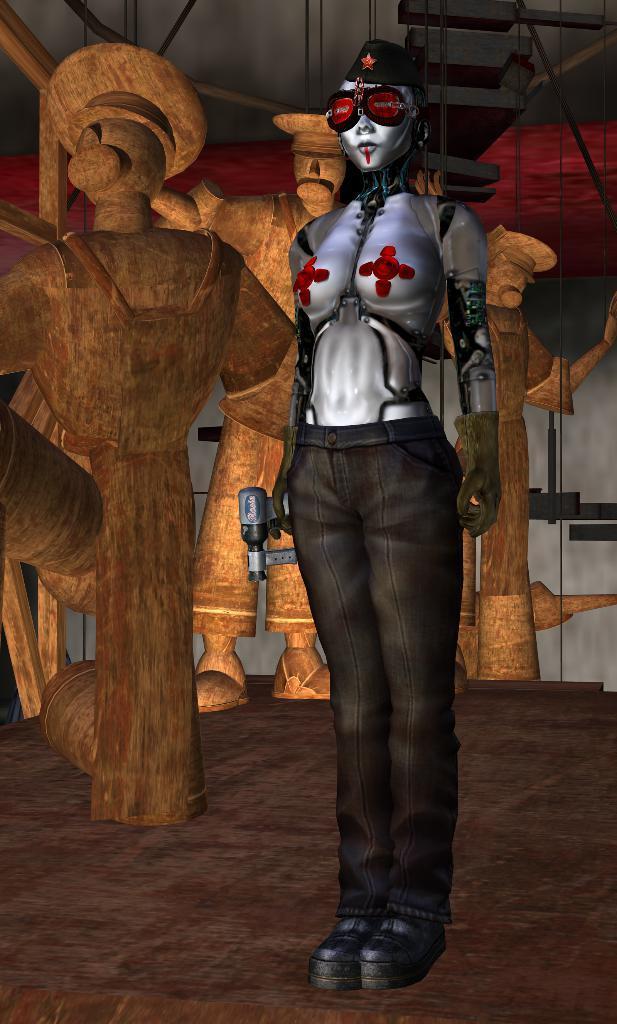How would you summarize this image in a sentence or two? This is an animated image. Here I can see animation of a person and other objects. 